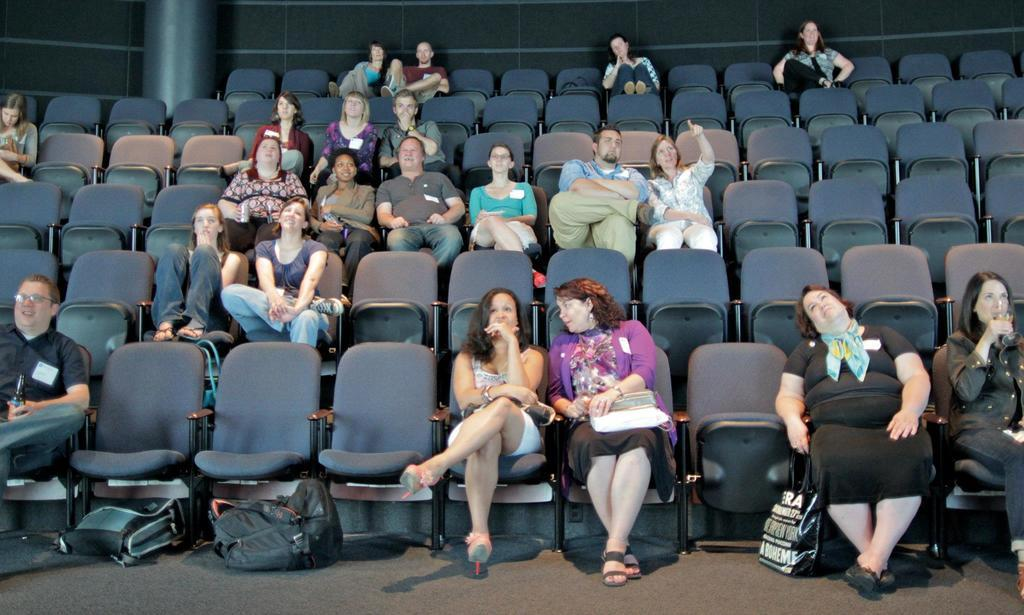What is the main activity of the people in the image? The people in the image are sitting on chairs. What can be seen on the floor in the image? There are some objects placed on the floor in the image. How many chairs are available in the image? There are many vacant chairs in the image. What type of coal is being used to fuel the steel furnace in the image? There is no coal or steel furnace present in the image; it features people sitting on chairs and objects on the floor. How many girls are visible in the image? There is no girl present in the image; it only shows people sitting on chairs and objects on the floor. 